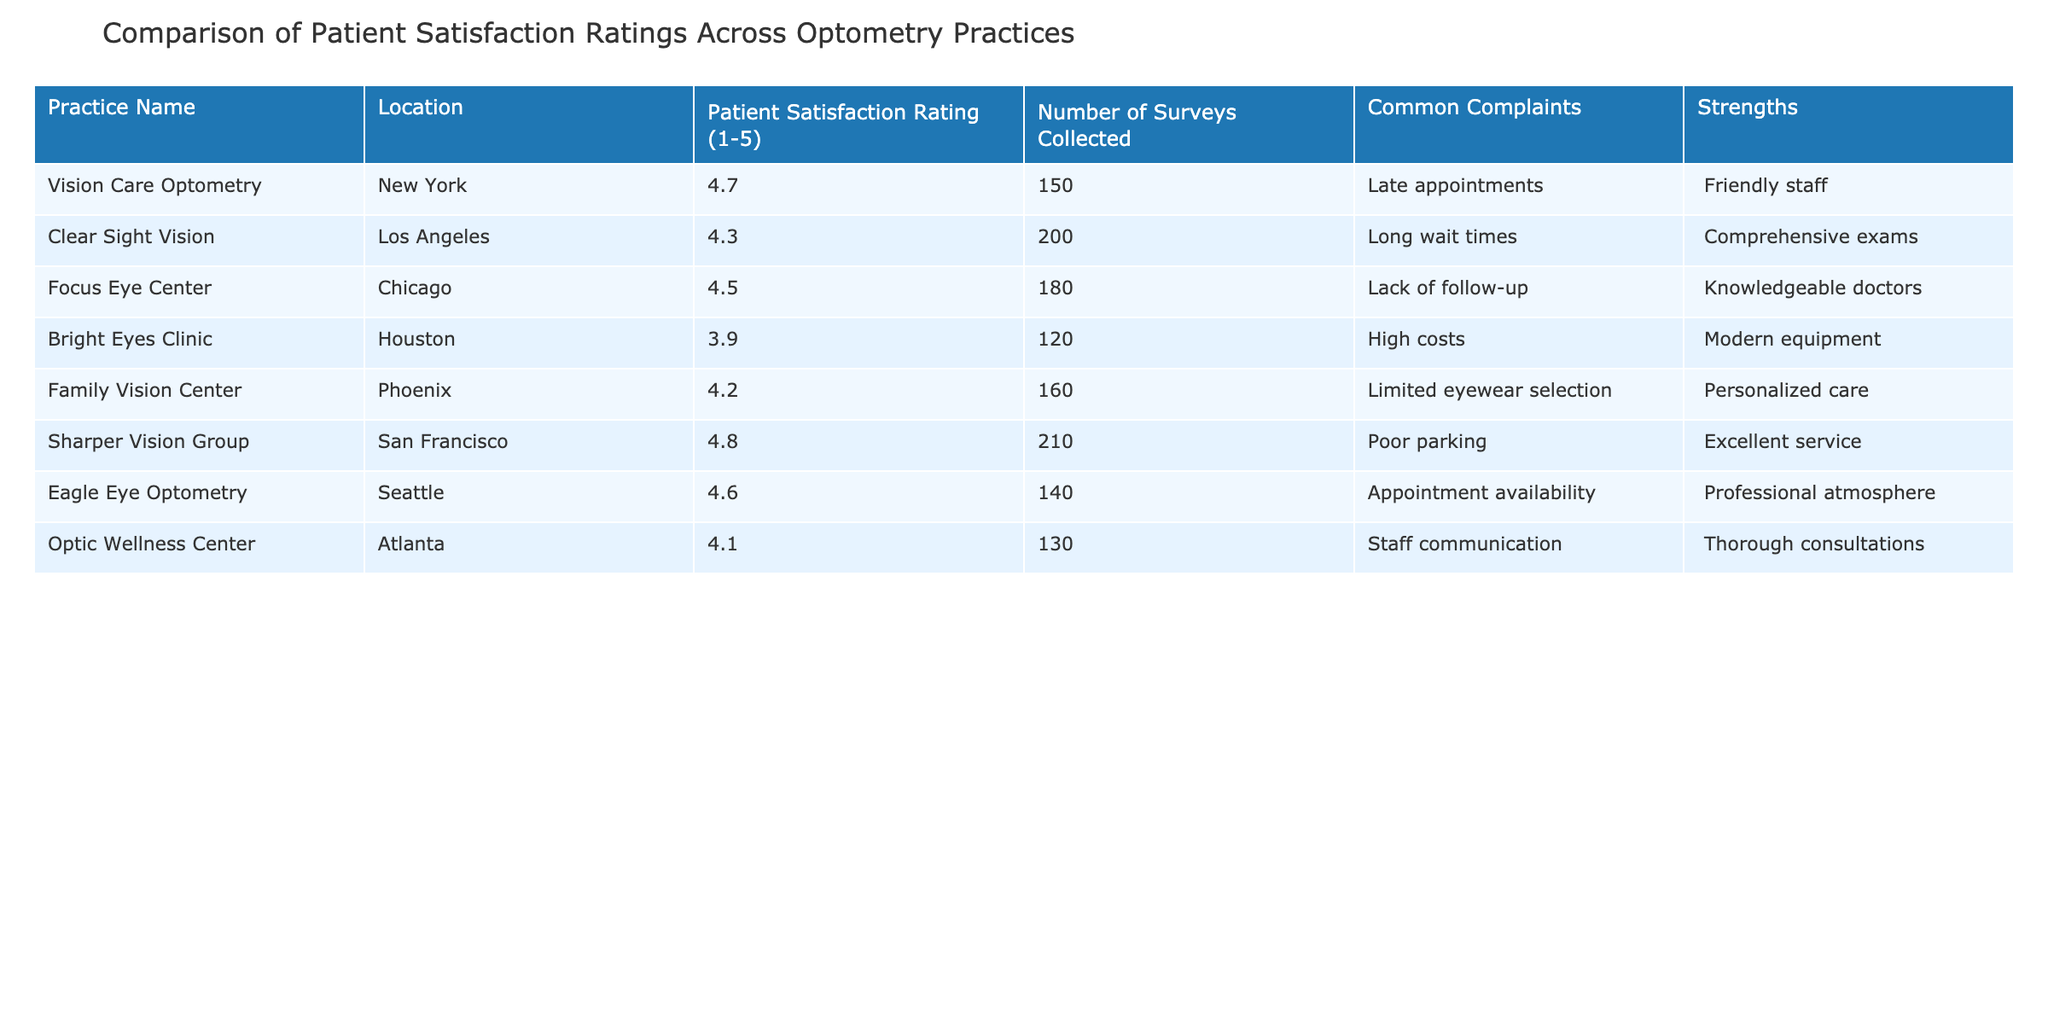What is the patient satisfaction rating for Sharper Vision Group? The patient satisfaction rating for Sharper Vision Group is listed directly in the table under "Patient Satisfaction Rating," where it shows a score of 4.8.
Answer: 4.8 What common complaint is mentioned for Bright Eyes Clinic? The common complaint for Bright Eyes Clinic is found in the "Common Complaints" column, which states "High costs."
Answer: High costs Which practice has the highest patient satisfaction rating, and what is that rating? The table lists Sharper Vision Group with the highest rating of 4.8, as seen in the "Patient Satisfaction Rating" column.
Answer: Sharper Vision Group, 4.8 What is the average patient satisfaction rating across all practices? To find the average, I sum the ratings: (4.7 + 4.3 + 4.5 + 3.9 + 4.2 + 4.8 + 4.6 + 4.1) = 30.1. Then divide by 8 (the number of practices), so 30.1 / 8 = 3.7625.
Answer: 3.76 Does Family Vision Center have more than 150 surveys collected? The number of surveys collected for Family Vision Center is 160, which is greater than 150. Therefore, the answer is true.
Answer: Yes What is the strength of the Focus Eye Center? The strength of Focus Eye Center is stated in the "Strengths" column as "Knowledgeable doctors."
Answer: Knowledgeable doctors Which practice has a patient satisfaction rating below 4? The only practice with a rating below 4 is Bright Eyes Clinic, which has a rating of 3.9, as seen in the "Patient Satisfaction Rating" column.
Answer: Bright Eyes Clinic If you combine the survey counts for Vision Care Optometry and Eagle Eye Optometry, what is the total? Vision Care Optometry has 150 surveys, and Eagle Eye Optometry has 140 surveys. Adding them together, 150 + 140 = 290.
Answer: 290 Is the appointment availability a common complaint for Eagle Eye Optometry? Yes, appointment availability is listed as a common complaint for Eagle Eye Optometry in the table.
Answer: Yes 